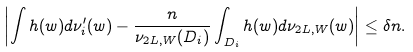Convert formula to latex. <formula><loc_0><loc_0><loc_500><loc_500>\left | \int h ( w ) d \nu ^ { \prime } _ { i } ( w ) - \frac { n } { \nu _ { 2 L , W } ( D _ { i } ) } \int _ { D _ { i } } h ( w ) d \nu _ { 2 L , W } ( w ) \right | \leq \delta n .</formula> 